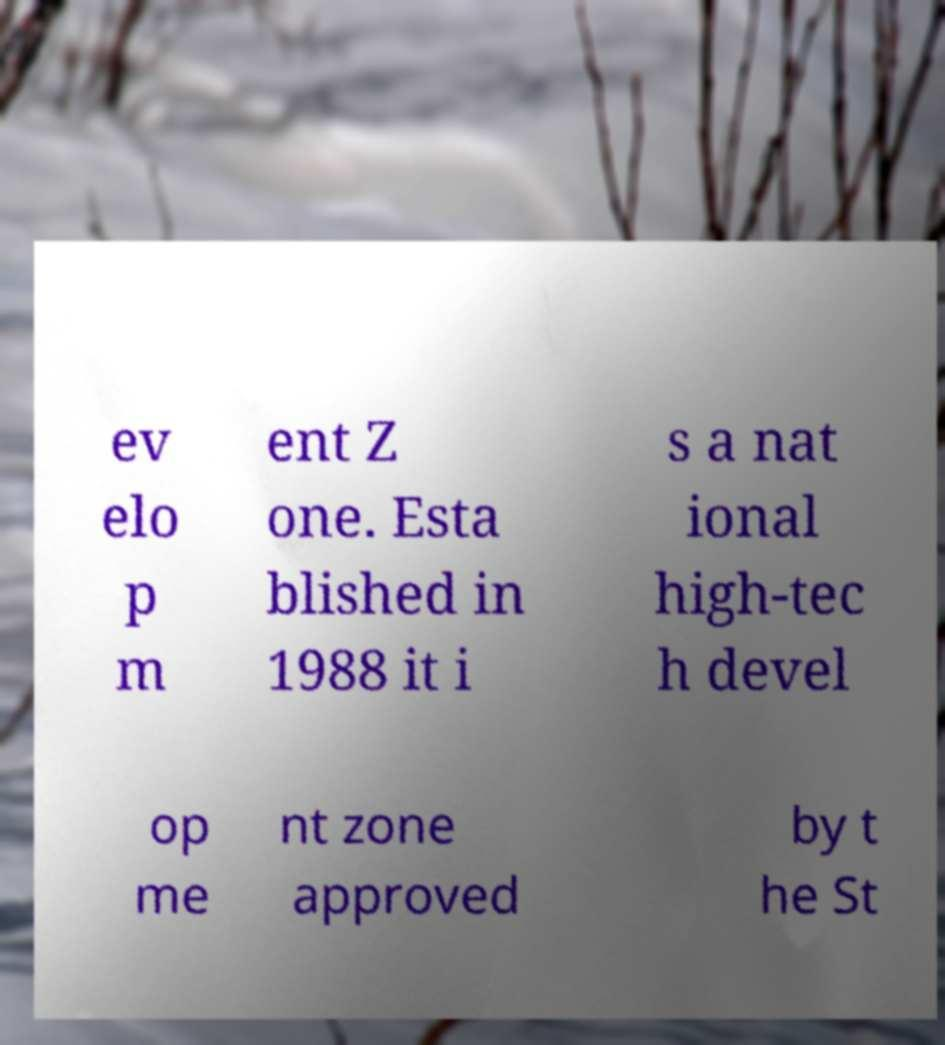Could you extract and type out the text from this image? ev elo p m ent Z one. Esta blished in 1988 it i s a nat ional high-tec h devel op me nt zone approved by t he St 